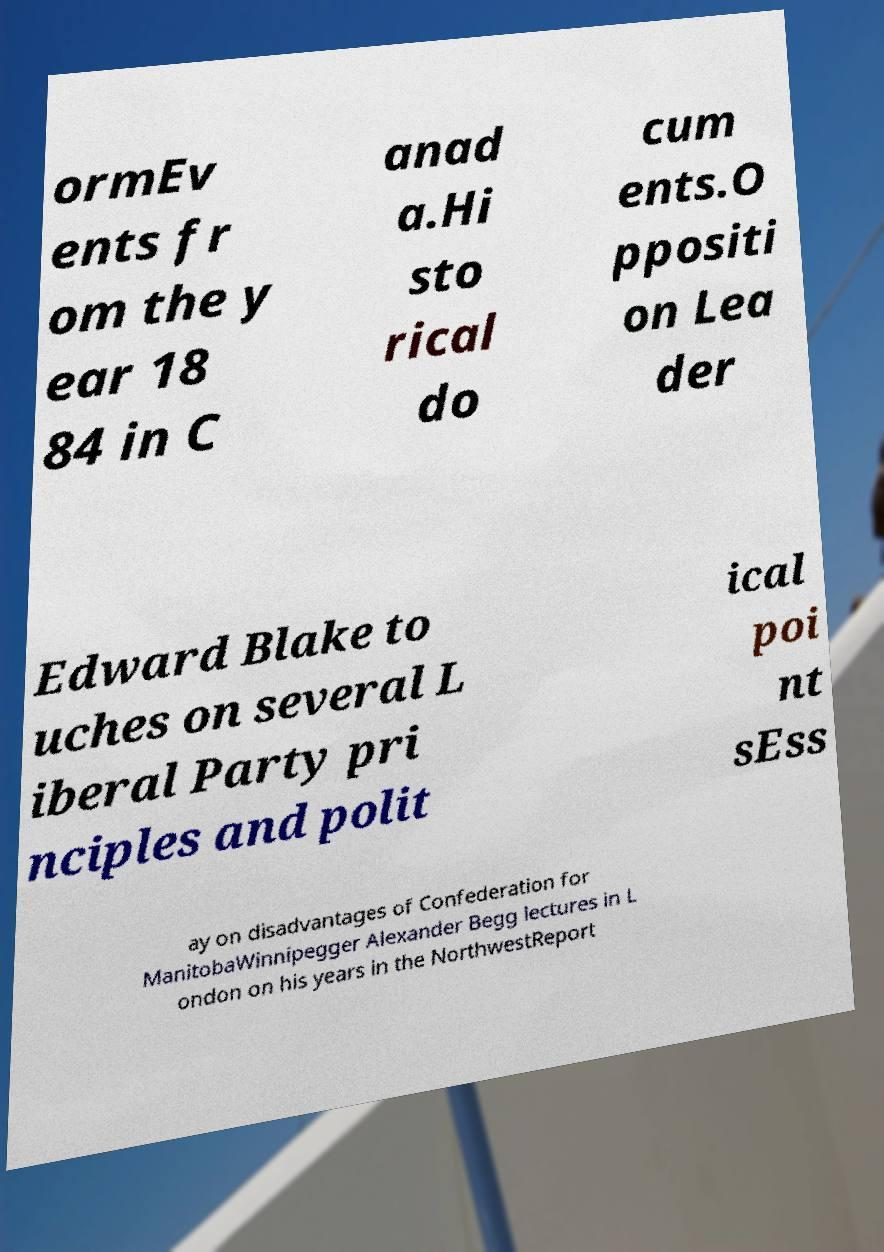I need the written content from this picture converted into text. Can you do that? ormEv ents fr om the y ear 18 84 in C anad a.Hi sto rical do cum ents.O ppositi on Lea der Edward Blake to uches on several L iberal Party pri nciples and polit ical poi nt sEss ay on disadvantages of Confederation for ManitobaWinnipegger Alexander Begg lectures in L ondon on his years in the NorthwestReport 